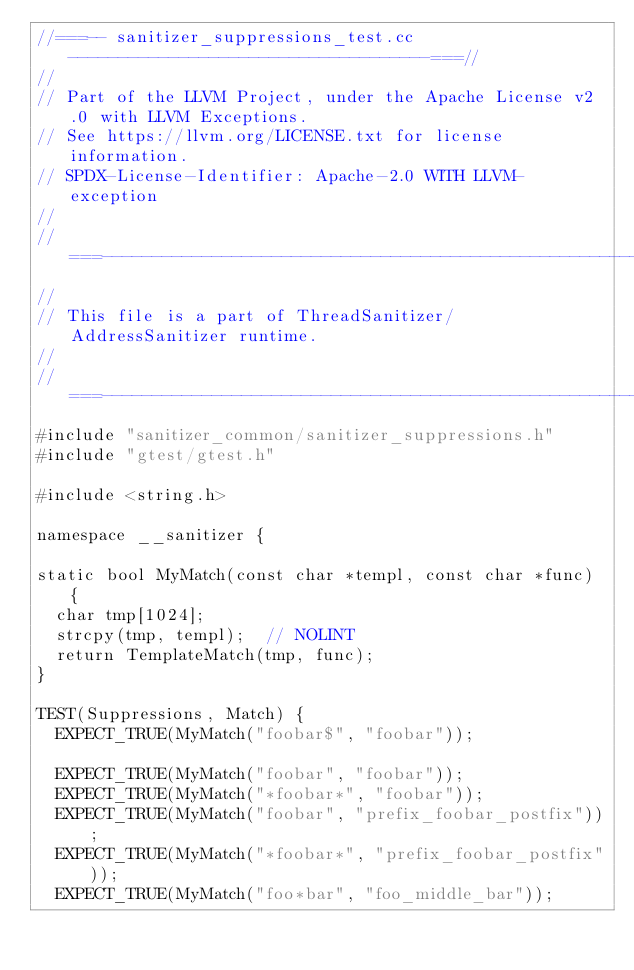<code> <loc_0><loc_0><loc_500><loc_500><_C++_>//===-- sanitizer_suppressions_test.cc ------------------------------------===//
//
// Part of the LLVM Project, under the Apache License v2.0 with LLVM Exceptions.
// See https://llvm.org/LICENSE.txt for license information.
// SPDX-License-Identifier: Apache-2.0 WITH LLVM-exception
//
//===----------------------------------------------------------------------===//
//
// This file is a part of ThreadSanitizer/AddressSanitizer runtime.
//
//===----------------------------------------------------------------------===//
#include "sanitizer_common/sanitizer_suppressions.h"
#include "gtest/gtest.h"

#include <string.h>

namespace __sanitizer {

static bool MyMatch(const char *templ, const char *func) {
  char tmp[1024];
  strcpy(tmp, templ);  // NOLINT
  return TemplateMatch(tmp, func);
}

TEST(Suppressions, Match) {
  EXPECT_TRUE(MyMatch("foobar$", "foobar"));

  EXPECT_TRUE(MyMatch("foobar", "foobar"));
  EXPECT_TRUE(MyMatch("*foobar*", "foobar"));
  EXPECT_TRUE(MyMatch("foobar", "prefix_foobar_postfix"));
  EXPECT_TRUE(MyMatch("*foobar*", "prefix_foobar_postfix"));
  EXPECT_TRUE(MyMatch("foo*bar", "foo_middle_bar"));</code> 